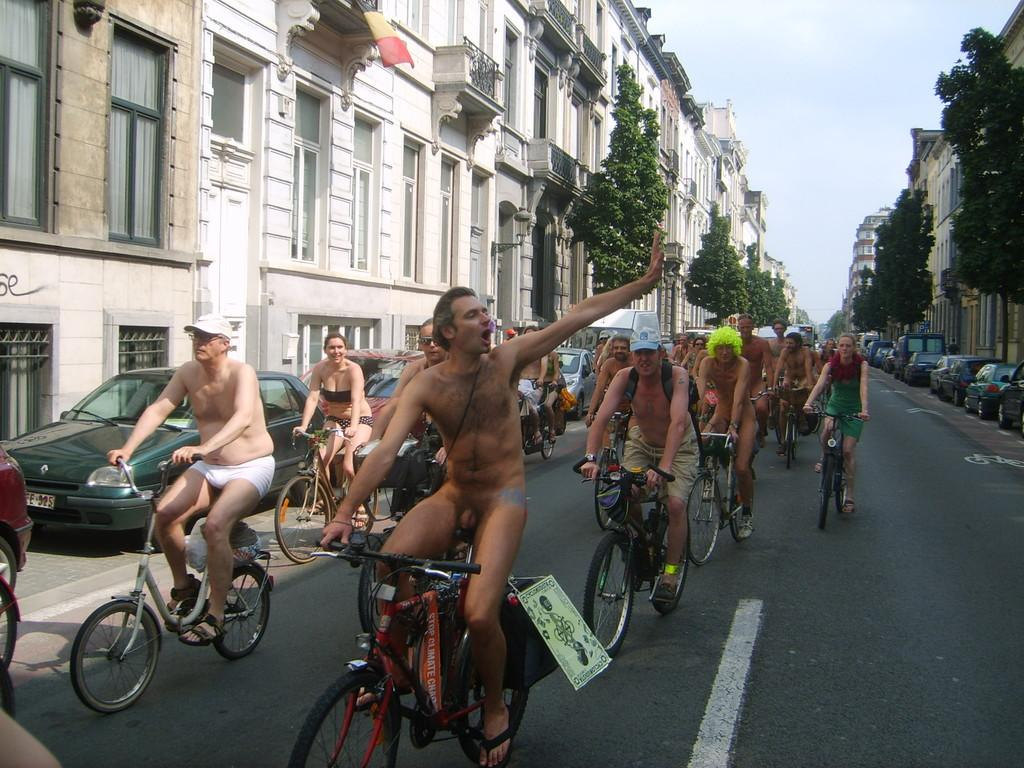What are the people in the image doing? The people in the image are riding bicycles on the road. What can be seen on either side of the road? There are buildings and trees on either side of the road. What is parked on the road? Cars are parked on the road. What type of pen is being used to write on the neck of the person riding a bicycle? There is no pen or writing activity present in the image; people are riding bicycles on the road. 